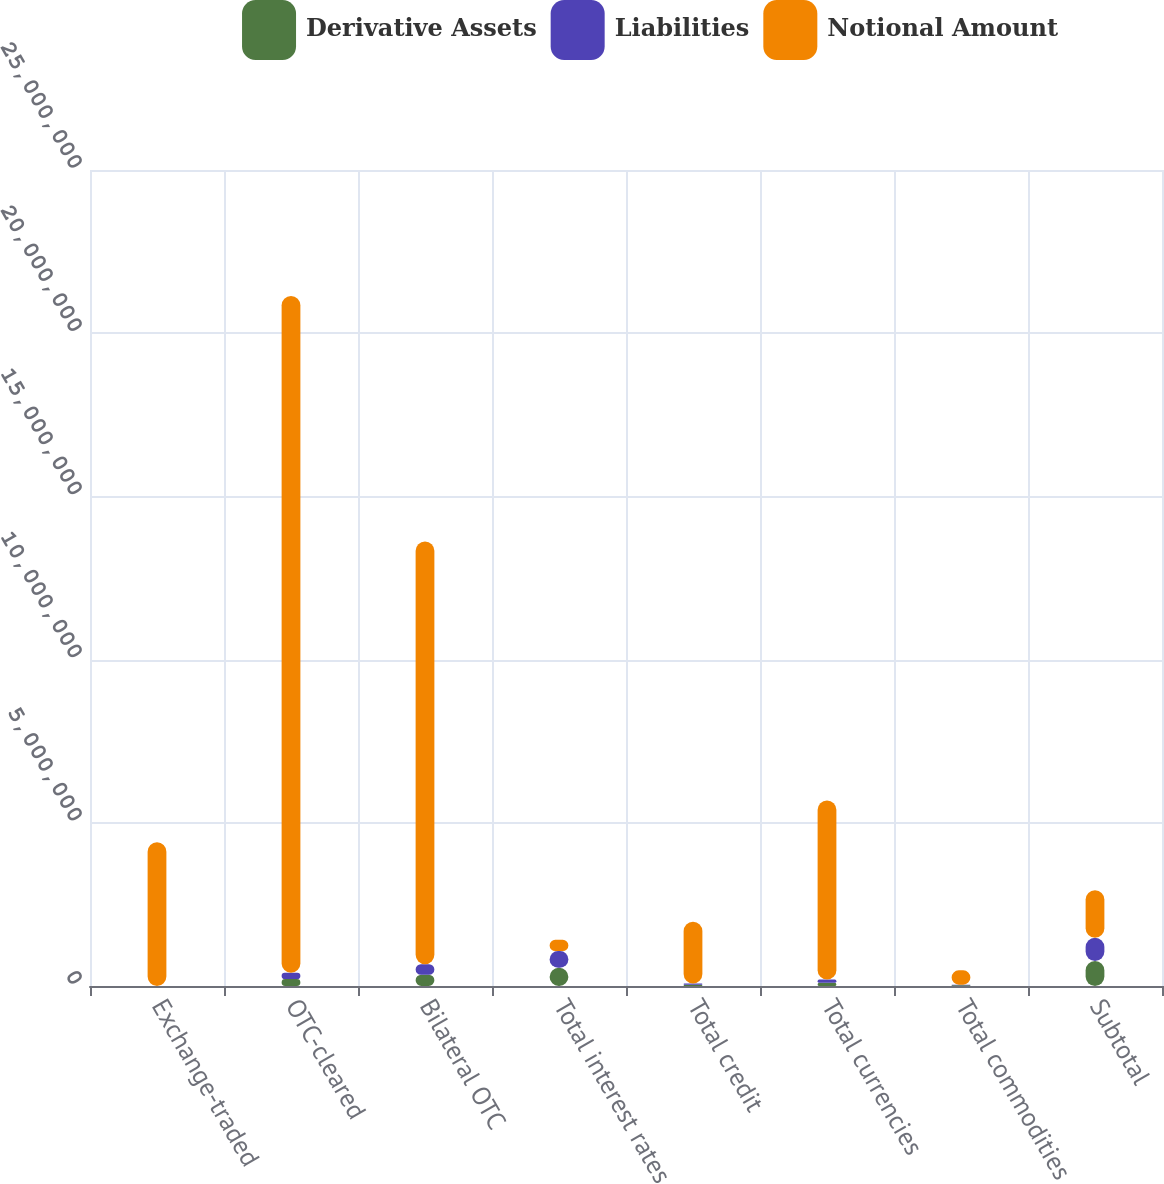<chart> <loc_0><loc_0><loc_500><loc_500><stacked_bar_chart><ecel><fcel>Exchange-traded<fcel>OTC-cleared<fcel>Bilateral OTC<fcel>Total interest rates<fcel>Total credit<fcel>Total currencies<fcel>Total commodities<fcel>Subtotal<nl><fcel>Derivative Assets<fcel>310<fcel>211272<fcel>345516<fcel>557098<fcel>40882<fcel>97008<fcel>20674<fcel>762822<nl><fcel>Liabilities<fcel>280<fcel>192401<fcel>321458<fcel>514139<fcel>36775<fcel>99567<fcel>21071<fcel>717750<nl><fcel>Notional Amount<fcel>4.40284e+06<fcel>2.07387e+07<fcel>1.29538e+07<fcel>345516<fcel>1.89205e+06<fcel>5.48963e+06<fcel>437054<fcel>1.4555e+06<nl></chart> 